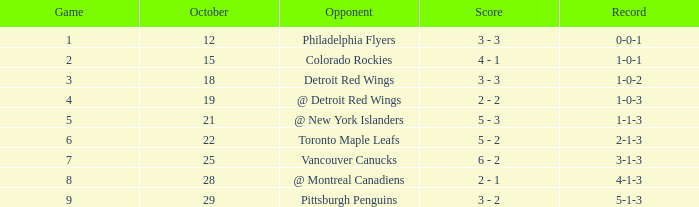Name the least game for record of 5-1-3 9.0. 